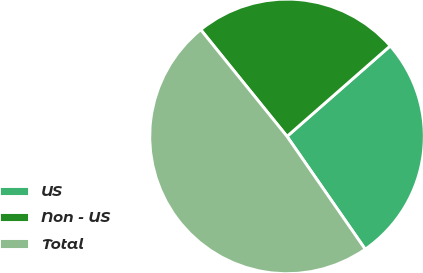Convert chart to OTSL. <chart><loc_0><loc_0><loc_500><loc_500><pie_chart><fcel>US<fcel>Non - US<fcel>Total<nl><fcel>26.81%<fcel>24.36%<fcel>48.82%<nl></chart> 